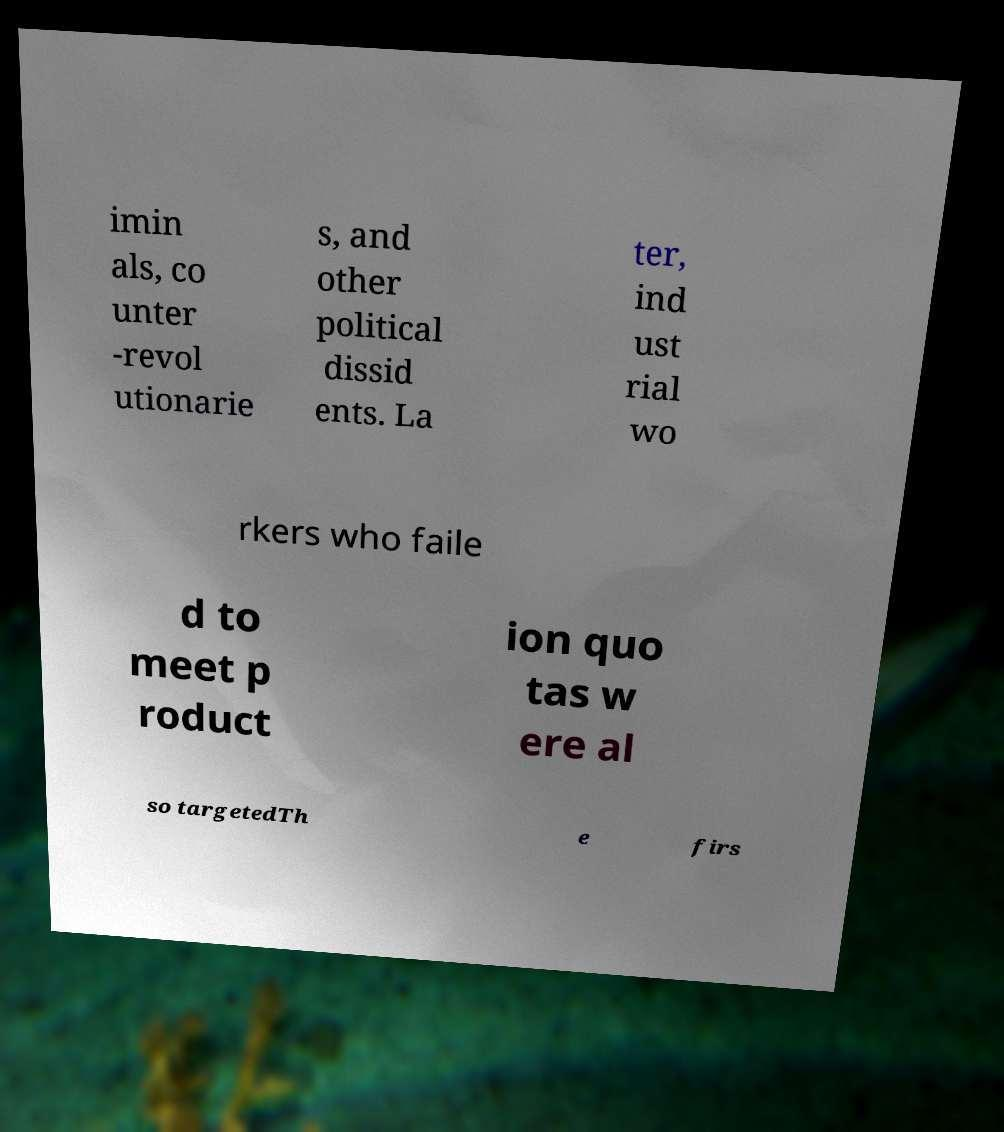Please read and relay the text visible in this image. What does it say? imin als, co unter -revol utionarie s, and other political dissid ents. La ter, ind ust rial wo rkers who faile d to meet p roduct ion quo tas w ere al so targetedTh e firs 